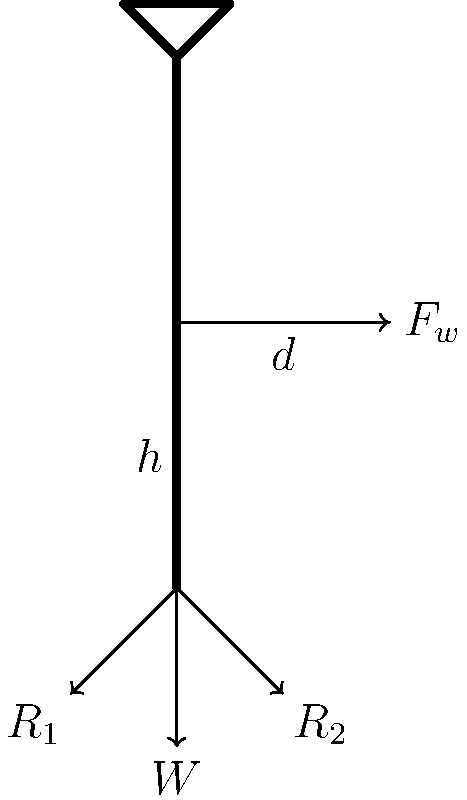Un diagrama de fuerzas muestra una torre de turbina eólica simplificada con una fuerza del viento $F_w$ aplicada a una altura $h$ desde la base. La torre tiene un peso $W$ y está soportada por dos reacciones en la base, $R_1$ y $R_2$. Si la distancia horizontal desde el centro de la torre hasta el punto de aplicación de $F_w$ es $d$, ¿cuál es la expresión para el momento de vuelco $M$ en la base de la torre? Para determinar el momento de vuelco en la base de la torre, seguimos estos pasos:

1) El momento de vuelco es causado por la fuerza del viento $F_w$ actuando a una distancia vertical $h$ desde la base.

2) El brazo de palanca para esta fuerza es la distancia perpendicular desde la línea de acción de la fuerza hasta el punto de rotación (la base de la torre).

3) Esta distancia perpendicular se compone de dos componentes:
   a) La altura $h$ a la que se aplica la fuerza
   b) La distancia horizontal $d$ desde el centro de la torre hasta el punto de aplicación de $F_w$

4) El brazo de palanca total es la raíz cuadrada de la suma de los cuadrados de estas dos componentes: $\sqrt{h^2 + d^2}$

5) El momento de vuelco $M$ se calcula multiplicando la fuerza por el brazo de palanca:

   $$M = F_w \cdot \sqrt{h^2 + d^2}$$

Esta expresión representa el momento de vuelco en la base de la torre debido a la fuerza del viento.
Answer: $M = F_w \cdot \sqrt{h^2 + d^2}$ 